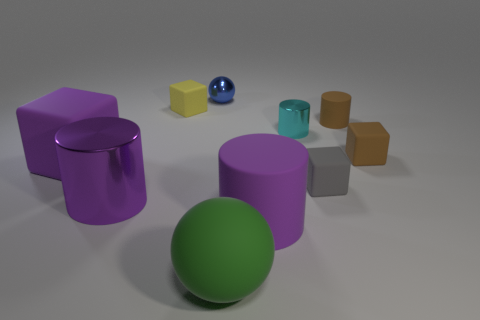Do the large purple thing that is on the right side of the small yellow rubber object and the cube that is in front of the large purple matte block have the same material?
Your answer should be very brief. Yes. There is a tiny thing that is the same color as the tiny matte cylinder; what is its material?
Provide a short and direct response. Rubber. What is the shape of the metal object that is in front of the blue sphere and to the right of the large purple metallic cylinder?
Offer a very short reply. Cylinder. There is a small cube behind the rubber cube right of the tiny brown cylinder; what is its material?
Offer a very short reply. Rubber. Is the number of yellow rubber cylinders greater than the number of large blocks?
Make the answer very short. No. Is the color of the small ball the same as the large shiny object?
Provide a short and direct response. No. There is a cyan cylinder that is the same size as the yellow matte block; what is it made of?
Offer a very short reply. Metal. Do the large green thing and the yellow thing have the same material?
Provide a short and direct response. Yes. What number of tiny cylinders are made of the same material as the small yellow object?
Provide a succinct answer. 1. How many objects are either cylinders that are on the left side of the small metallic cylinder or tiny shiny things behind the small cyan object?
Provide a short and direct response. 3. 